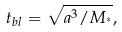Convert formula to latex. <formula><loc_0><loc_0><loc_500><loc_500>t _ { b l } = \sqrt { a ^ { 3 } / M _ { ^ { * } } } ,</formula> 